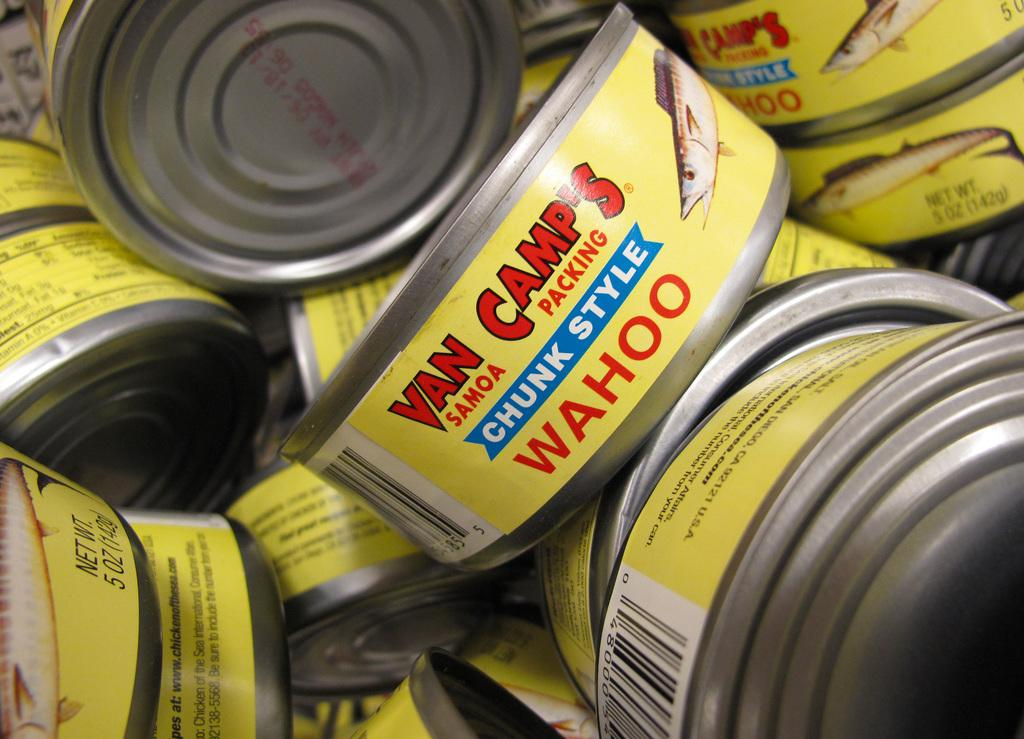Provide a one-sentence caption for the provided image. Many cans of chunk style Wahoo from Van Camp's. 